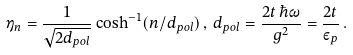Convert formula to latex. <formula><loc_0><loc_0><loc_500><loc_500>\eta _ { n } = \frac { 1 } { \sqrt { 2 d _ { p o l } } } \cosh ^ { - 1 } ( n / d _ { p o l } ) \, , \, d _ { p o l } = \frac { 2 t \, \hbar { \omega } } { g ^ { 2 } } = \frac { 2 t } { \varepsilon _ { p } } \, .</formula> 